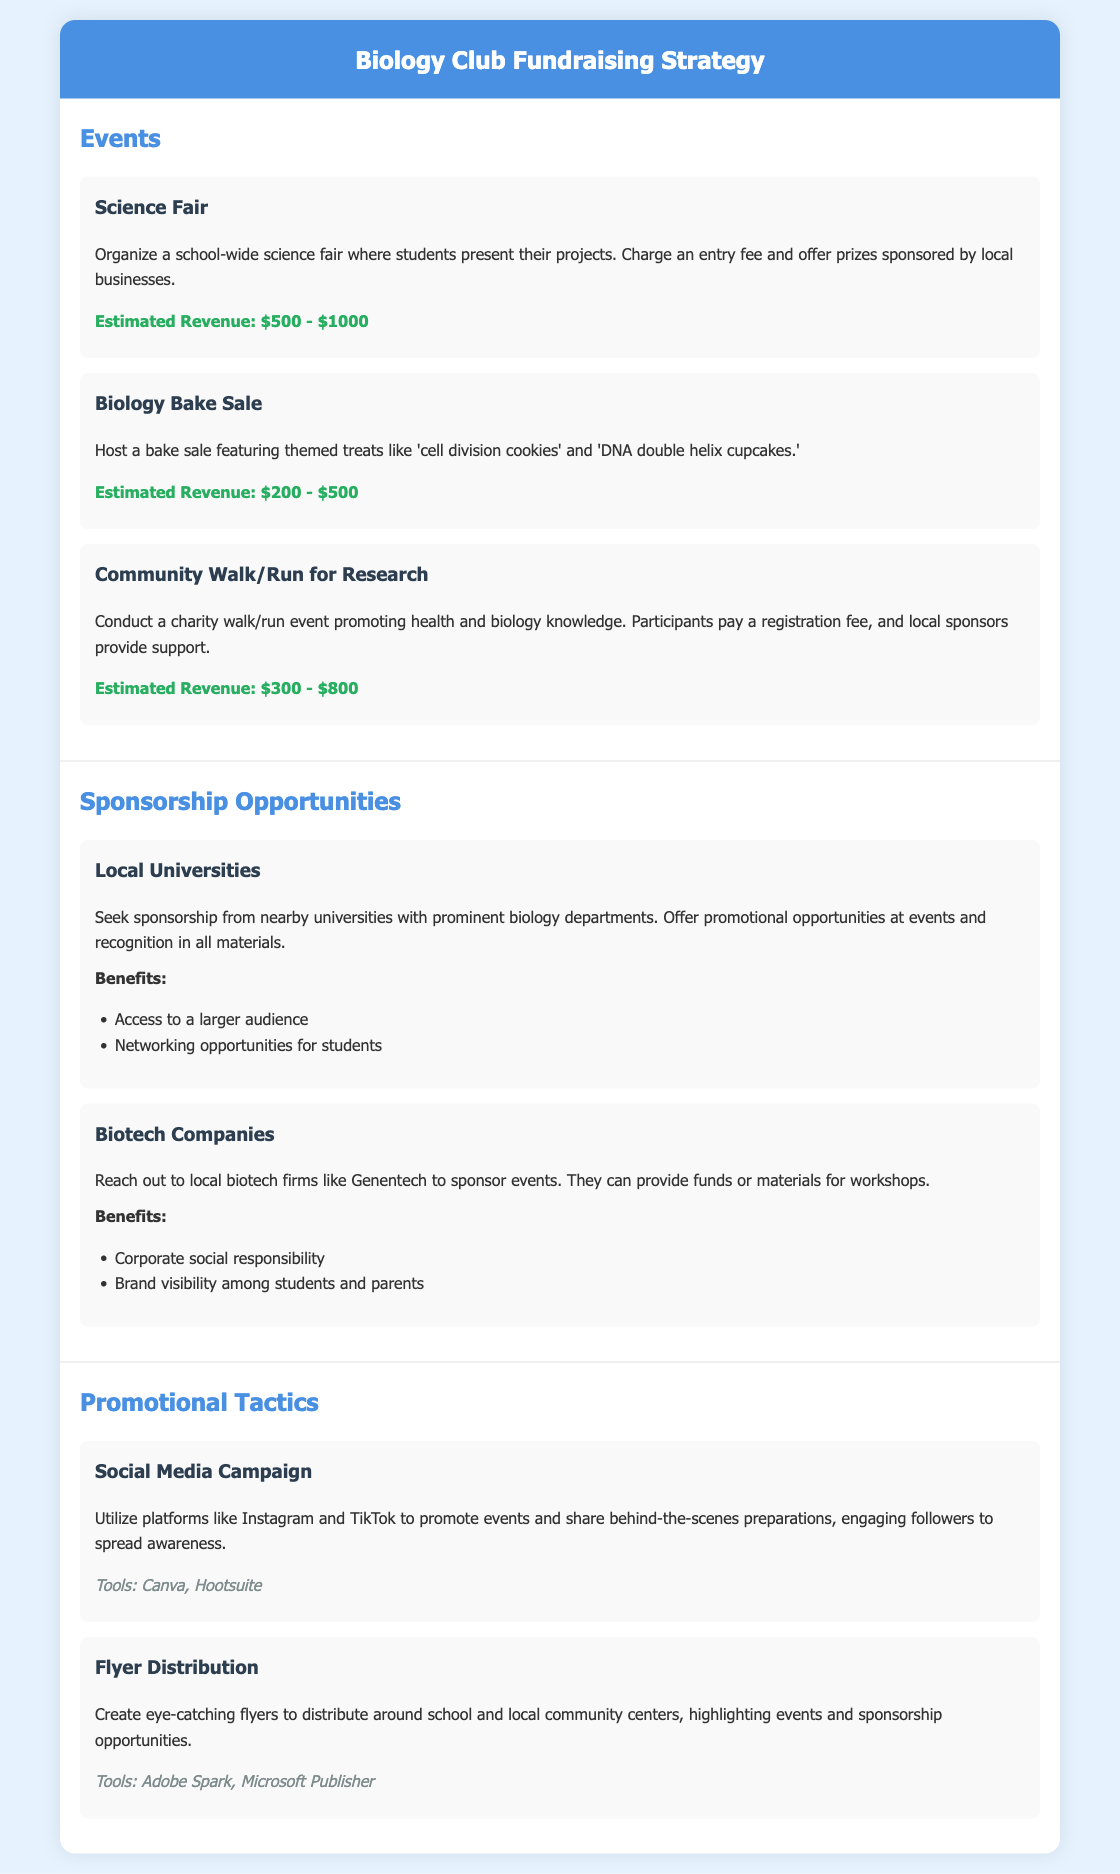What is the estimated revenue from the Science Fair? The estimated revenue for the Science Fair is listed in the document as between $500 and $1000.
Answer: $500 - $1000 What type of event is a Biology Bake Sale? The Biology Bake Sale is described as a bake sale featuring themed treats.
Answer: Bake sale What company is mentioned as a potential sponsor for events? The document suggests reaching out to local biotech firms, specifically mentioning Genentech as a potential sponsor.
Answer: Genentech What social media platforms are suggested for the promotional campaign? The document recommends using Instagram and TikTok for promoting events.
Answer: Instagram and TikTok How many estimated revenue sources are listed in the document? The document lists three events, each with an estimated revenue, making a total of three sources.
Answer: Three 